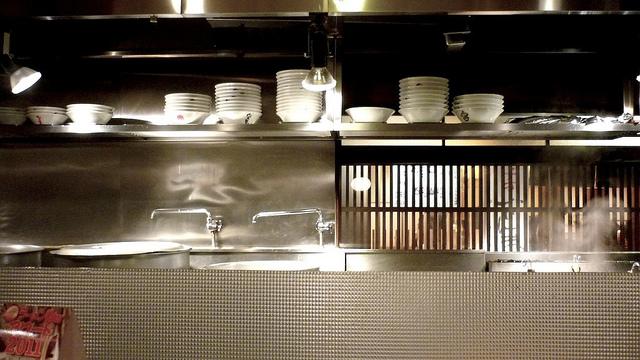What color are the dishes?
Be succinct. White. Is this a big kitchen?
Give a very brief answer. Yes. Why is there a reflection under the sink?
Quick response, please. Light. 